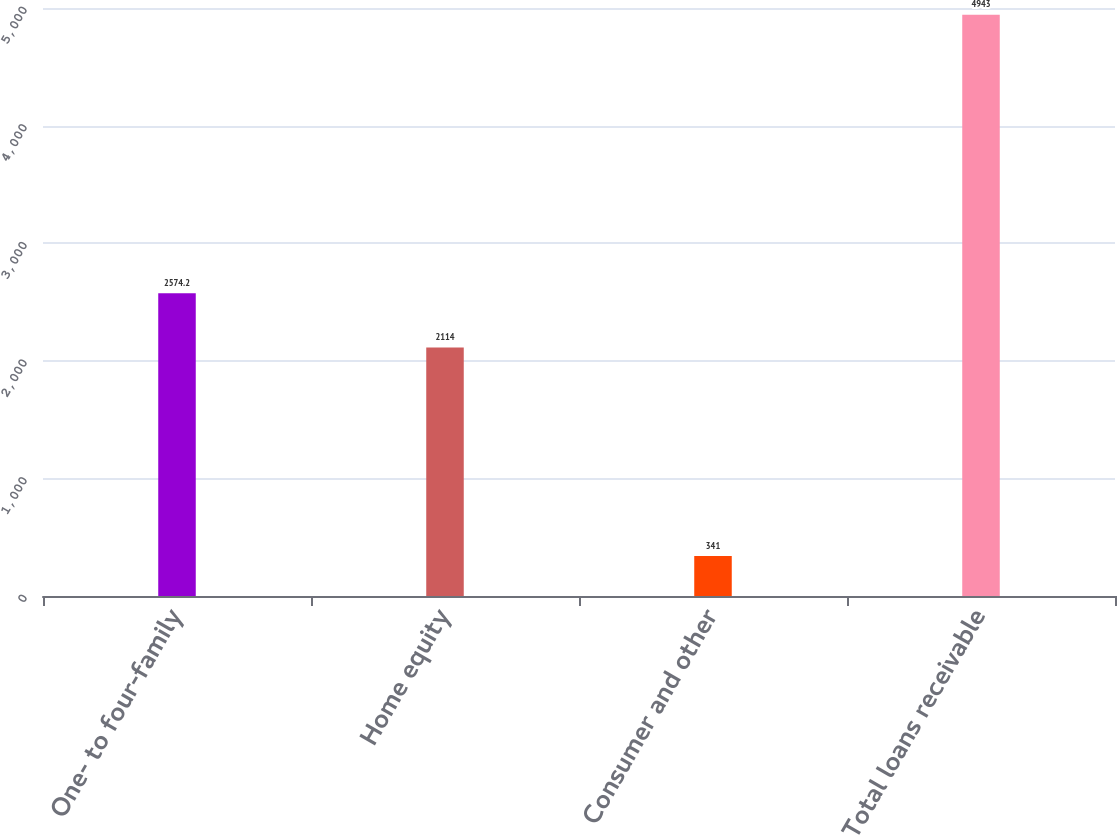<chart> <loc_0><loc_0><loc_500><loc_500><bar_chart><fcel>One- to four-family<fcel>Home equity<fcel>Consumer and other<fcel>Total loans receivable<nl><fcel>2574.2<fcel>2114<fcel>341<fcel>4943<nl></chart> 